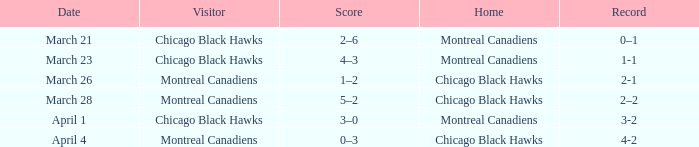What is the team's score that has a 2-1 record? 1–2. 